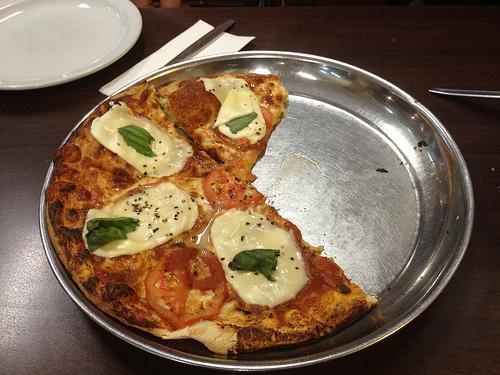How many plates are there?
Give a very brief answer. 2. 